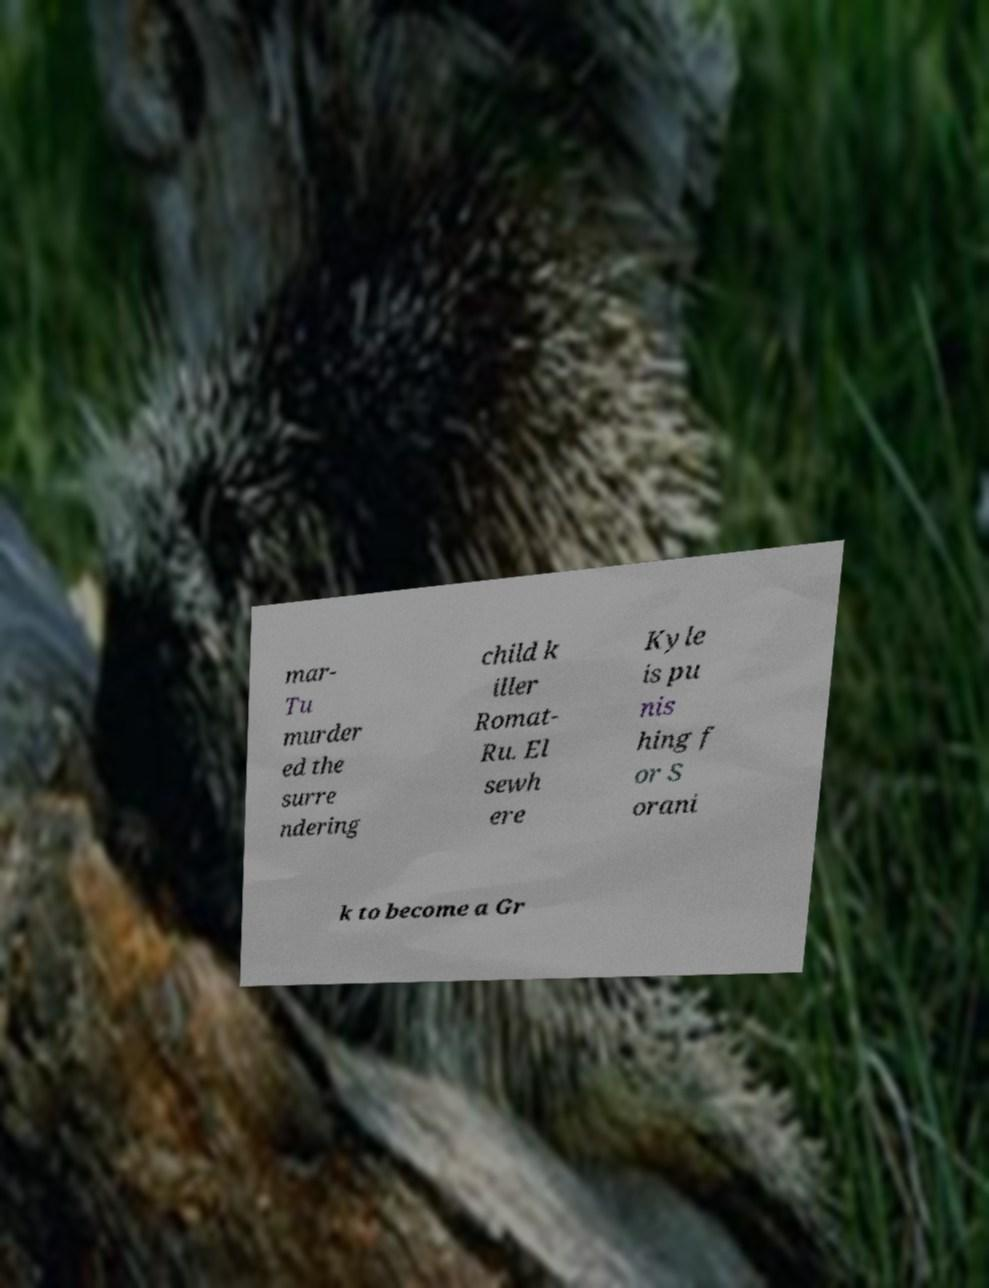Can you accurately transcribe the text from the provided image for me? mar- Tu murder ed the surre ndering child k iller Romat- Ru. El sewh ere Kyle is pu nis hing f or S orani k to become a Gr 